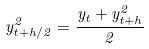Convert formula to latex. <formula><loc_0><loc_0><loc_500><loc_500>y _ { t + h / 2 } ^ { 2 } = \frac { y _ { t } + y _ { t + h } ^ { 2 } } { 2 }</formula> 